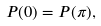Convert formula to latex. <formula><loc_0><loc_0><loc_500><loc_500>P ( 0 ) = P ( \pi ) ,</formula> 